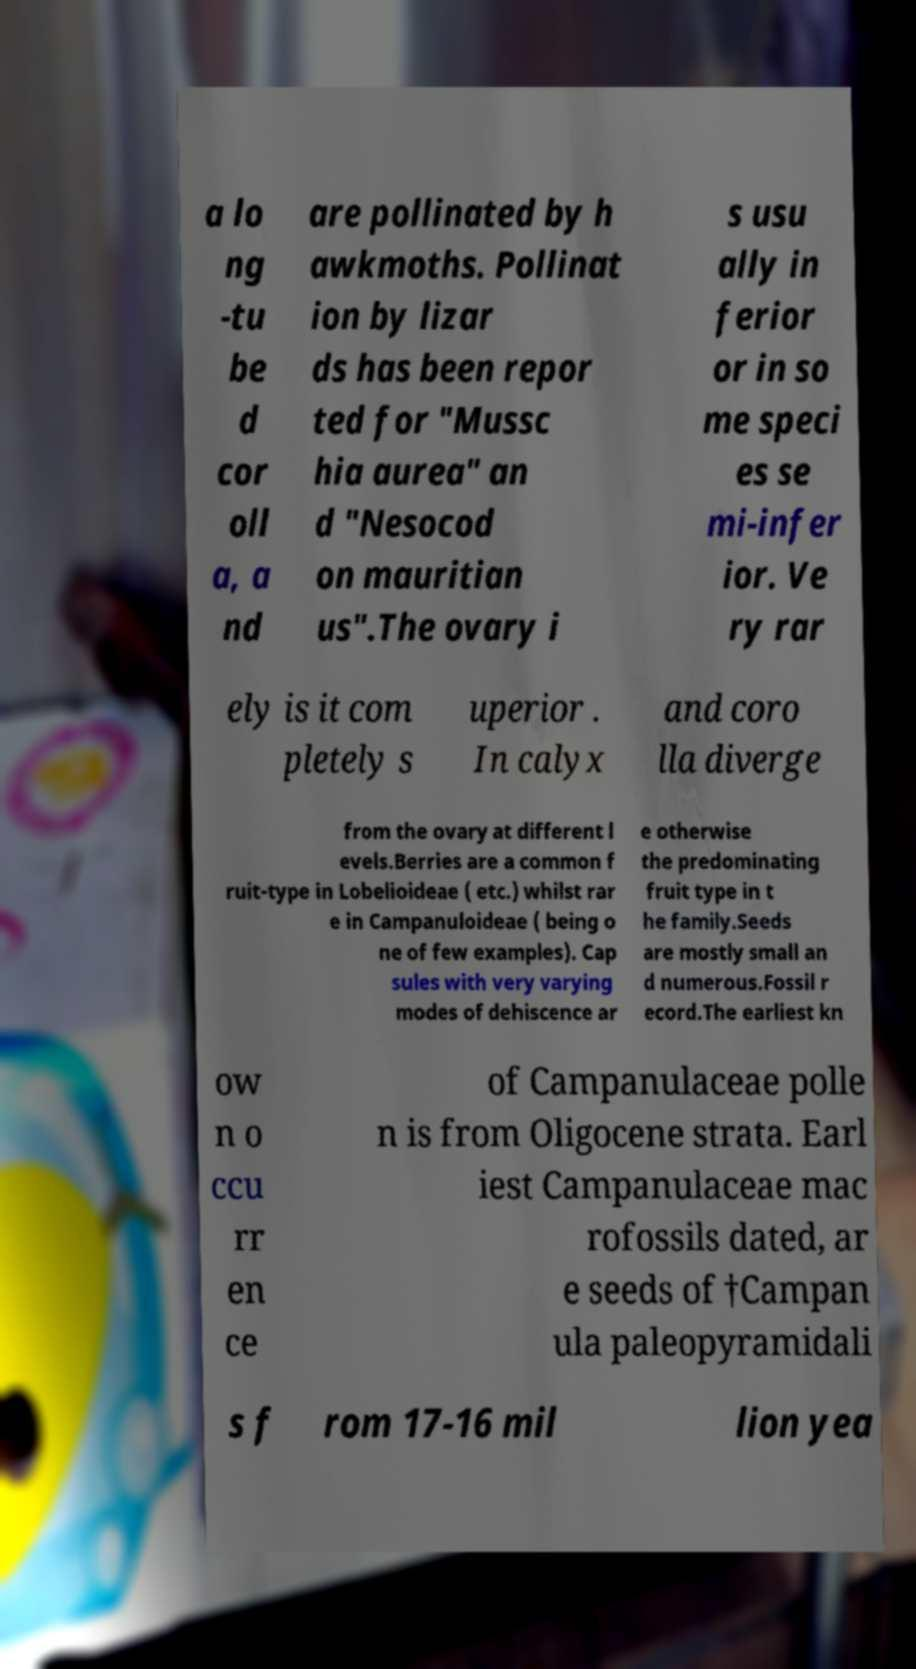For documentation purposes, I need the text within this image transcribed. Could you provide that? a lo ng -tu be d cor oll a, a nd are pollinated by h awkmoths. Pollinat ion by lizar ds has been repor ted for "Mussc hia aurea" an d "Nesocod on mauritian us".The ovary i s usu ally in ferior or in so me speci es se mi-infer ior. Ve ry rar ely is it com pletely s uperior . In calyx and coro lla diverge from the ovary at different l evels.Berries are a common f ruit-type in Lobelioideae ( etc.) whilst rar e in Campanuloideae ( being o ne of few examples). Cap sules with very varying modes of dehiscence ar e otherwise the predominating fruit type in t he family.Seeds are mostly small an d numerous.Fossil r ecord.The earliest kn ow n o ccu rr en ce of Campanulaceae polle n is from Oligocene strata. Earl iest Campanulaceae mac rofossils dated, ar e seeds of †Campan ula paleopyramidali s f rom 17-16 mil lion yea 